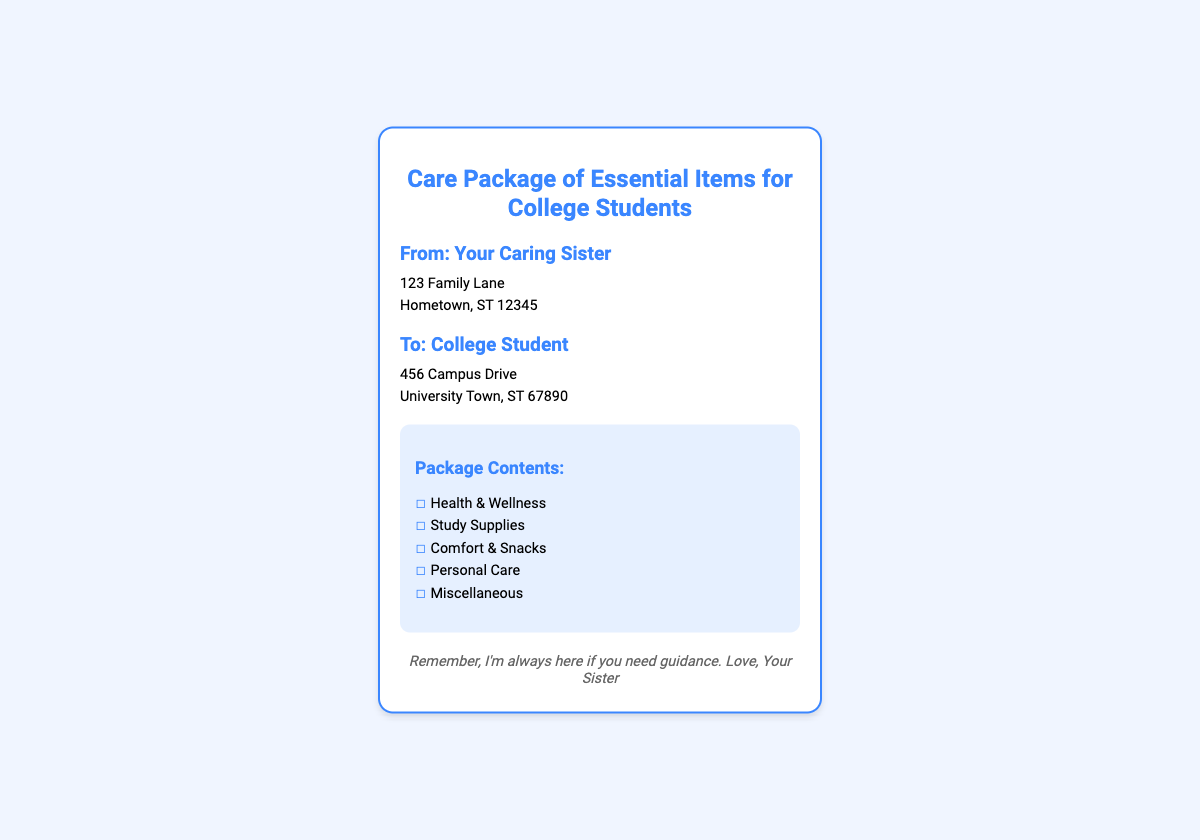what is the title of the package? The title of the package is stated at the top of the document.
Answer: Care Package of Essential Items for College Students who is the sender of the package? The sender is mentioned in the sender section of the document.
Answer: Your Caring Sister what is the address of the recipient? The address of the recipient can be found in the recipient section.
Answer: 456 Campus Drive, University Town, ST 67890 how many categories are listed in the package contents? The number of categories is based on the items listed in the checklist.
Answer: five name one category included in the checklist. One of the categories listed in the checklist is mentioned clearly.
Answer: Health & Wellness what color is used for the heading text? The document specifies a color for the headings throughout.
Answer: #3a86ff is there a note included in the package? The presence of a note is indicated in the document under a specific section.
Answer: Yes who is the note from? The note specifies who it is from at the end of the document.
Answer: Your Sister 